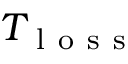Convert formula to latex. <formula><loc_0><loc_0><loc_500><loc_500>T _ { l o s s }</formula> 